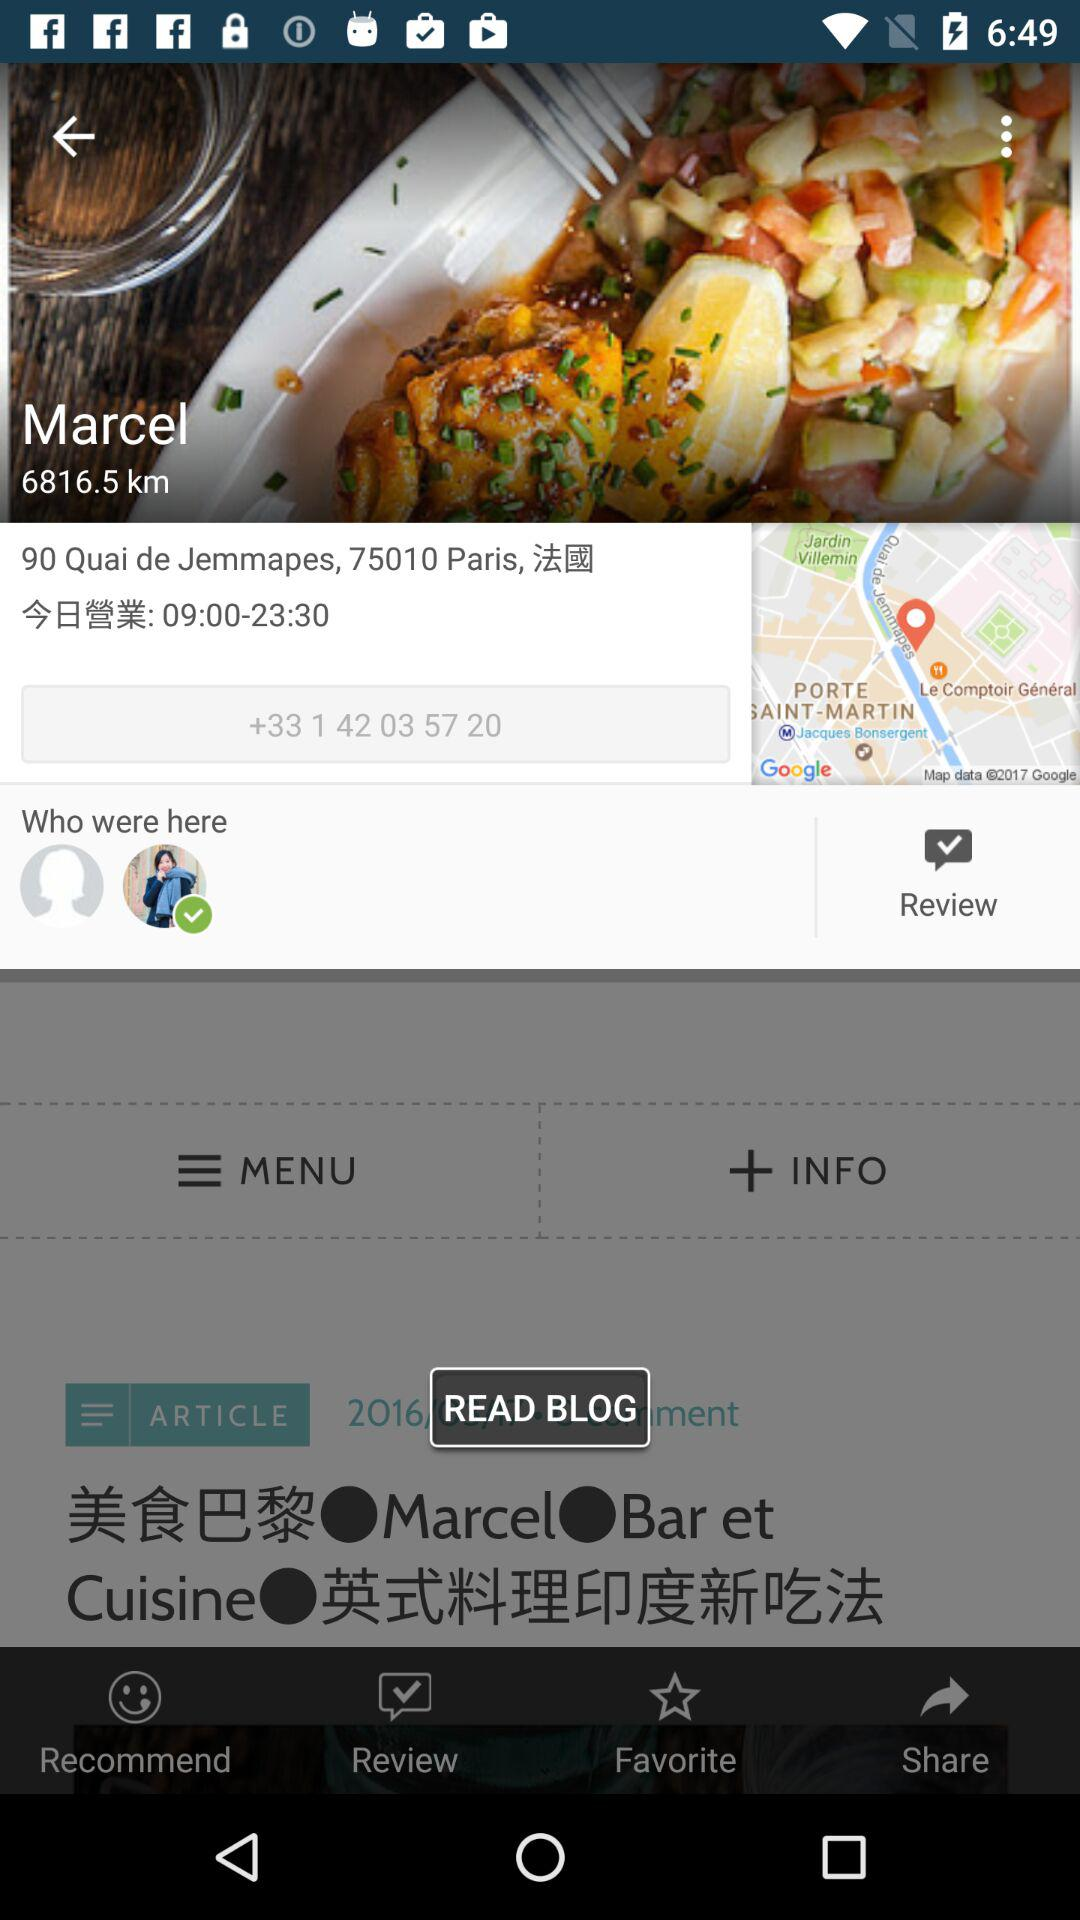What is the distance shown on the screen? The distance shown on the screen is 6816.5 km. 